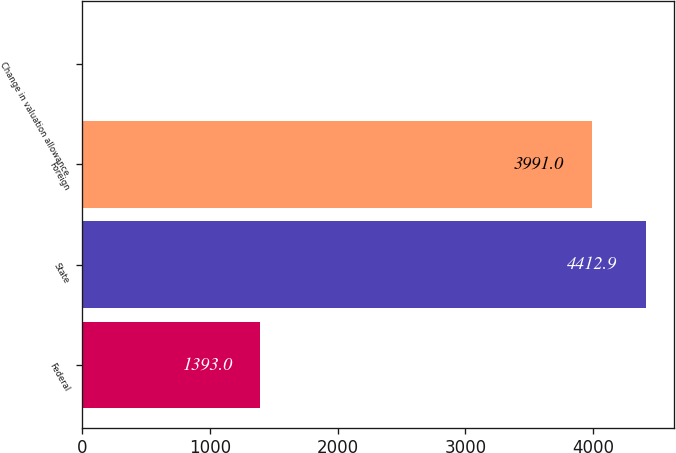Convert chart. <chart><loc_0><loc_0><loc_500><loc_500><bar_chart><fcel>Federal<fcel>State<fcel>Foreign<fcel>Change in valuation allowance<nl><fcel>1393<fcel>4412.9<fcel>3991<fcel>10<nl></chart> 